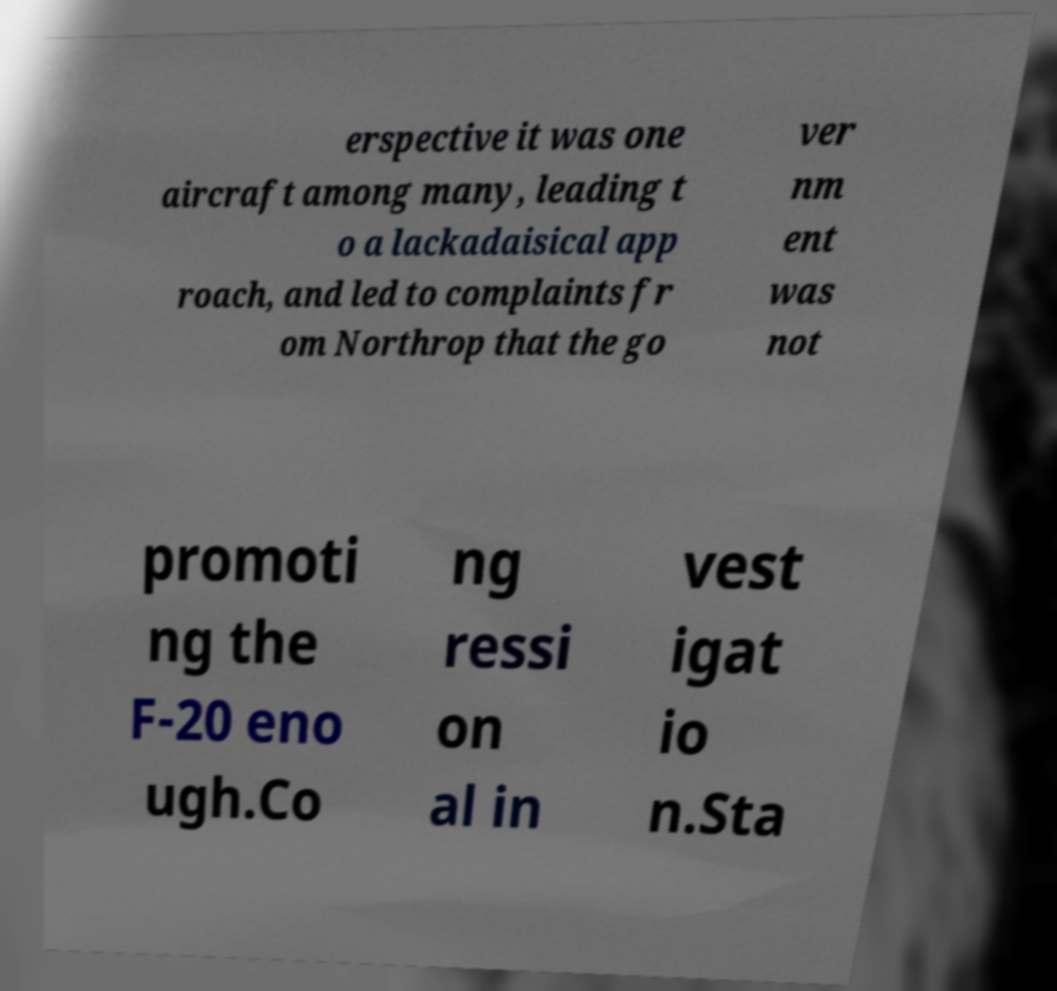What messages or text are displayed in this image? I need them in a readable, typed format. erspective it was one aircraft among many, leading t o a lackadaisical app roach, and led to complaints fr om Northrop that the go ver nm ent was not promoti ng the F-20 eno ugh.Co ng ressi on al in vest igat io n.Sta 